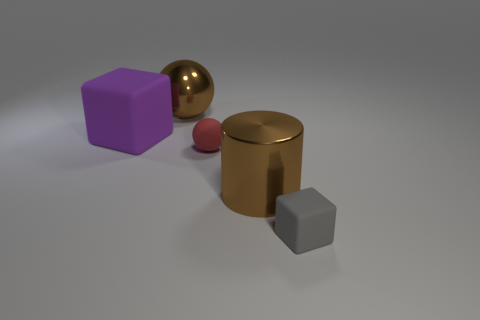Add 1 large metal balls. How many objects exist? 6 Subtract all gray cubes. How many cubes are left? 1 Subtract 1 cylinders. How many cylinders are left? 0 Subtract all large yellow shiny cylinders. Subtract all metallic balls. How many objects are left? 4 Add 1 large rubber cubes. How many large rubber cubes are left? 2 Add 5 red balls. How many red balls exist? 6 Subtract 0 green blocks. How many objects are left? 5 Subtract all cylinders. How many objects are left? 4 Subtract all cyan cylinders. Subtract all blue blocks. How many cylinders are left? 1 Subtract all red cylinders. How many gray cubes are left? 1 